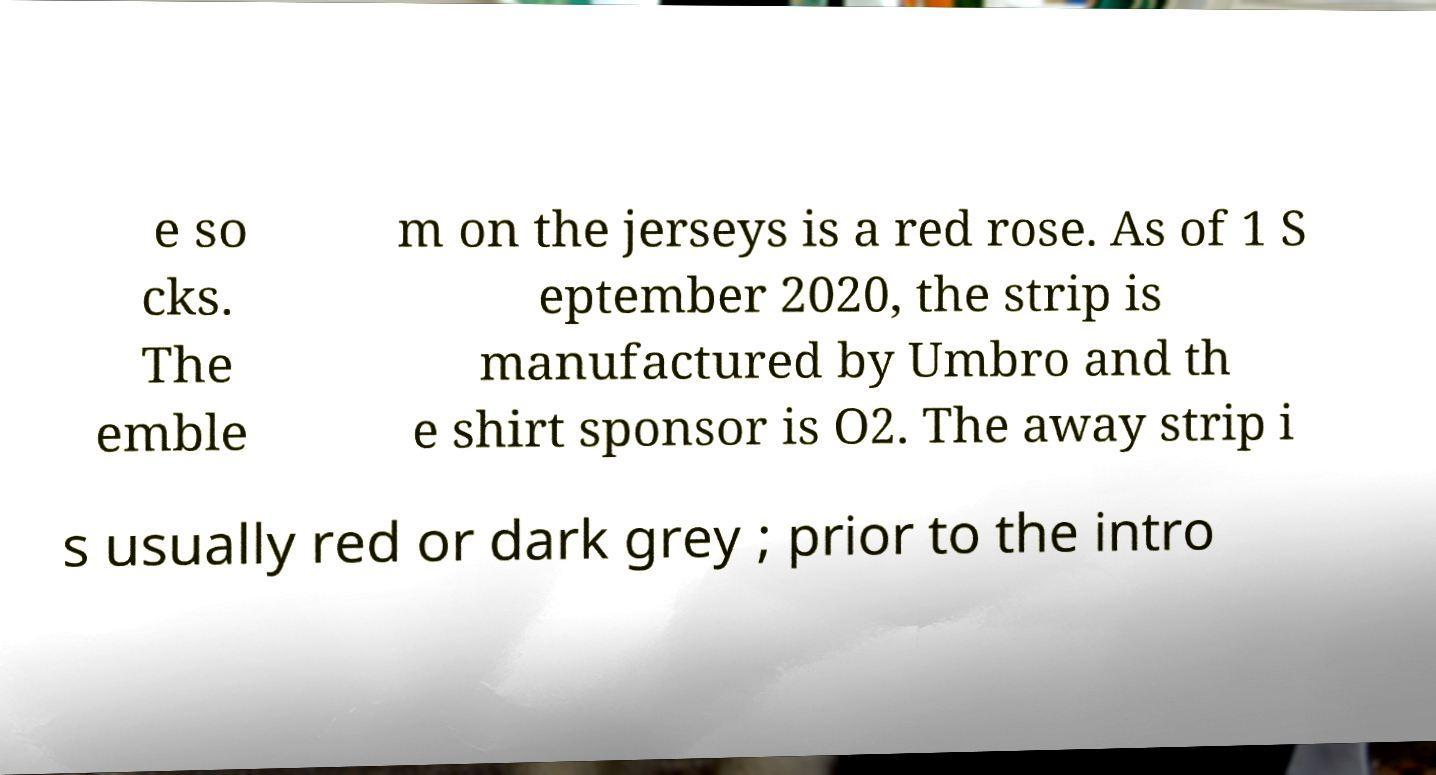Can you read and provide the text displayed in the image?This photo seems to have some interesting text. Can you extract and type it out for me? e so cks. The emble m on the jerseys is a red rose. As of 1 S eptember 2020, the strip is manufactured by Umbro and th e shirt sponsor is O2. The away strip i s usually red or dark grey ; prior to the intro 